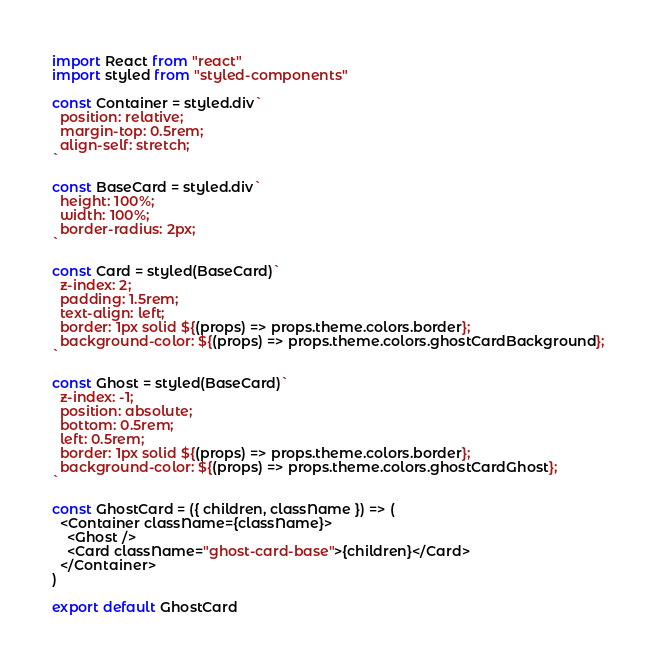<code> <loc_0><loc_0><loc_500><loc_500><_JavaScript_>import React from "react"
import styled from "styled-components"

const Container = styled.div`
  position: relative;
  margin-top: 0.5rem;
  align-self: stretch;
`

const BaseCard = styled.div`
  height: 100%;
  width: 100%;
  border-radius: 2px;
`

const Card = styled(BaseCard)`
  z-index: 2;
  padding: 1.5rem;
  text-align: left;
  border: 1px solid ${(props) => props.theme.colors.border};
  background-color: ${(props) => props.theme.colors.ghostCardBackground};
`

const Ghost = styled(BaseCard)`
  z-index: -1;
  position: absolute;
  bottom: 0.5rem;
  left: 0.5rem;
  border: 1px solid ${(props) => props.theme.colors.border};
  background-color: ${(props) => props.theme.colors.ghostCardGhost};
`

const GhostCard = ({ children, className }) => (
  <Container className={className}>
    <Ghost />
    <Card className="ghost-card-base">{children}</Card>
  </Container>
)

export default GhostCard
</code> 